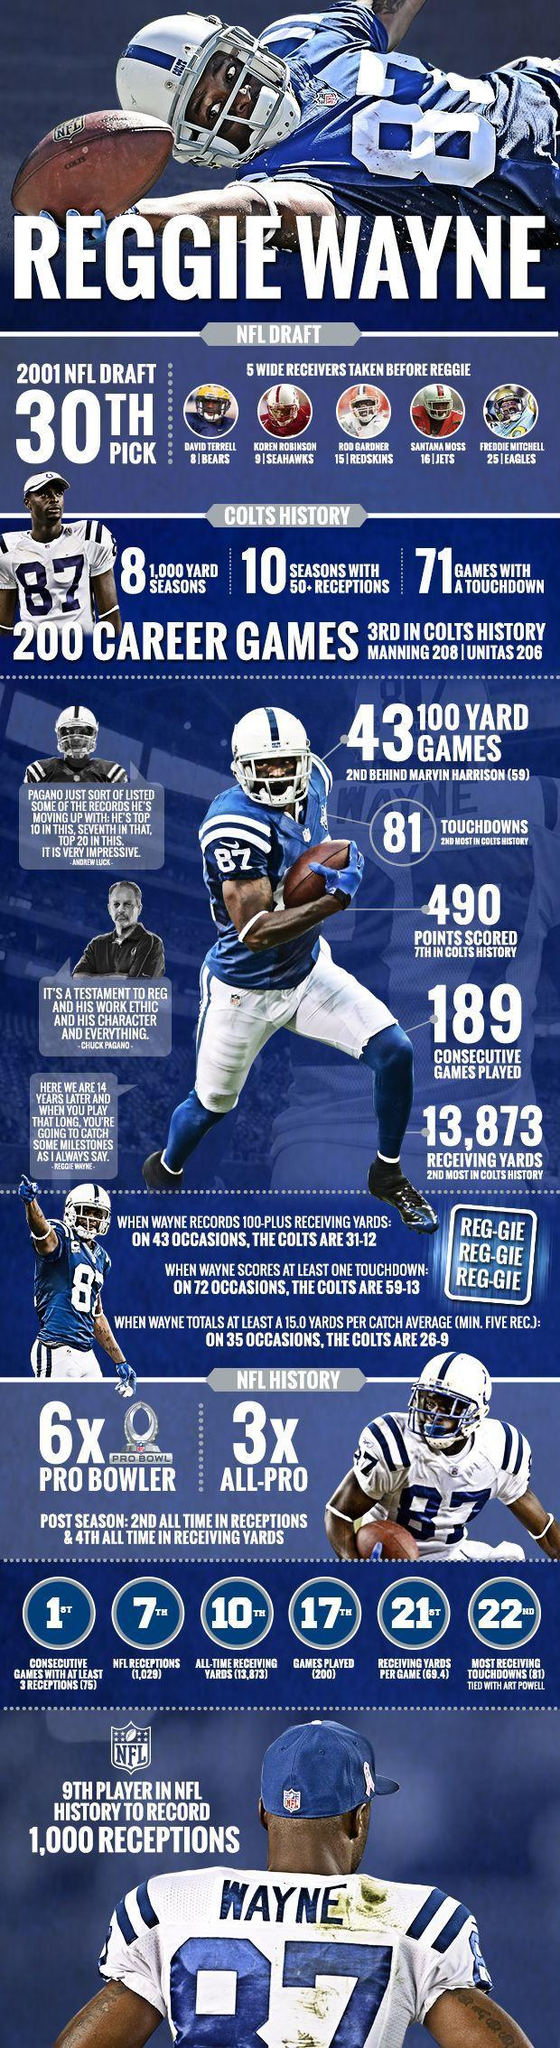To which team Koren Robinson belongs?
Answer the question with a short phrase. SeaHawks How many times Reggie Wayne became All-Pro? 3x To which team Santana Moss belongs? Jets What is the Jersey number of Santana Moss? 16 